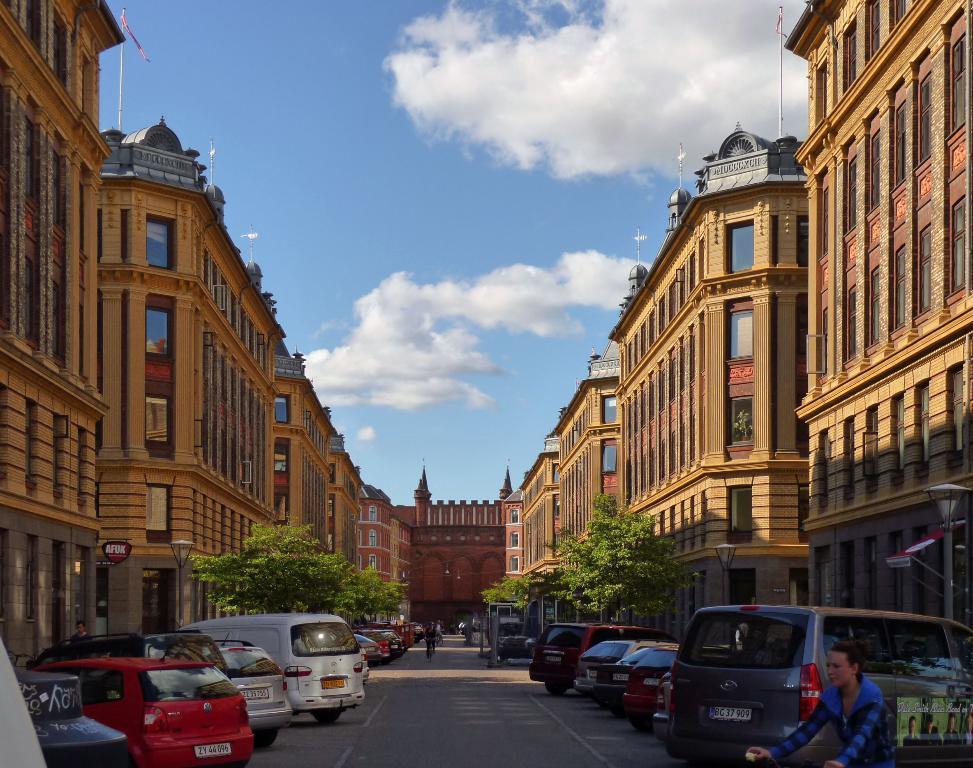Please provide a concise description of this image. In this image I see number of cars, road and I see few people and in the background I see the buildings, trees and the clear sky. 